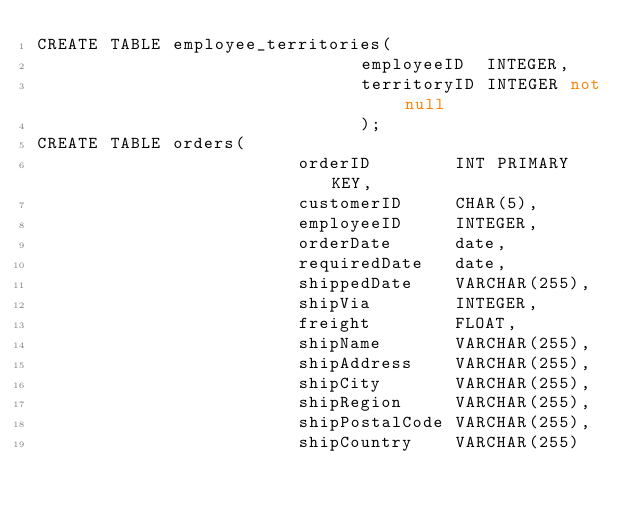<code> <loc_0><loc_0><loc_500><loc_500><_SQL_>CREATE TABLE employee_territories(
                               employeeID  INTEGER,
                               territoryID INTEGER not null
                               );
CREATE TABLE orders(
                         orderID        INT PRIMARY KEY,
                         customerID     CHAR(5),
                         employeeID     INTEGER,
                         orderDate      date,
                         requiredDate   date,
                         shippedDate    VARCHAR(255),
                         shipVia        INTEGER,
                         freight        FLOAT,
                         shipName       VARCHAR(255),
                         shipAddress    VARCHAR(255),
                         shipCity       VARCHAR(255),
                         shipRegion     VARCHAR(255),
                         shipPostalCode VARCHAR(255),
                         shipCountry    VARCHAR(255)</code> 